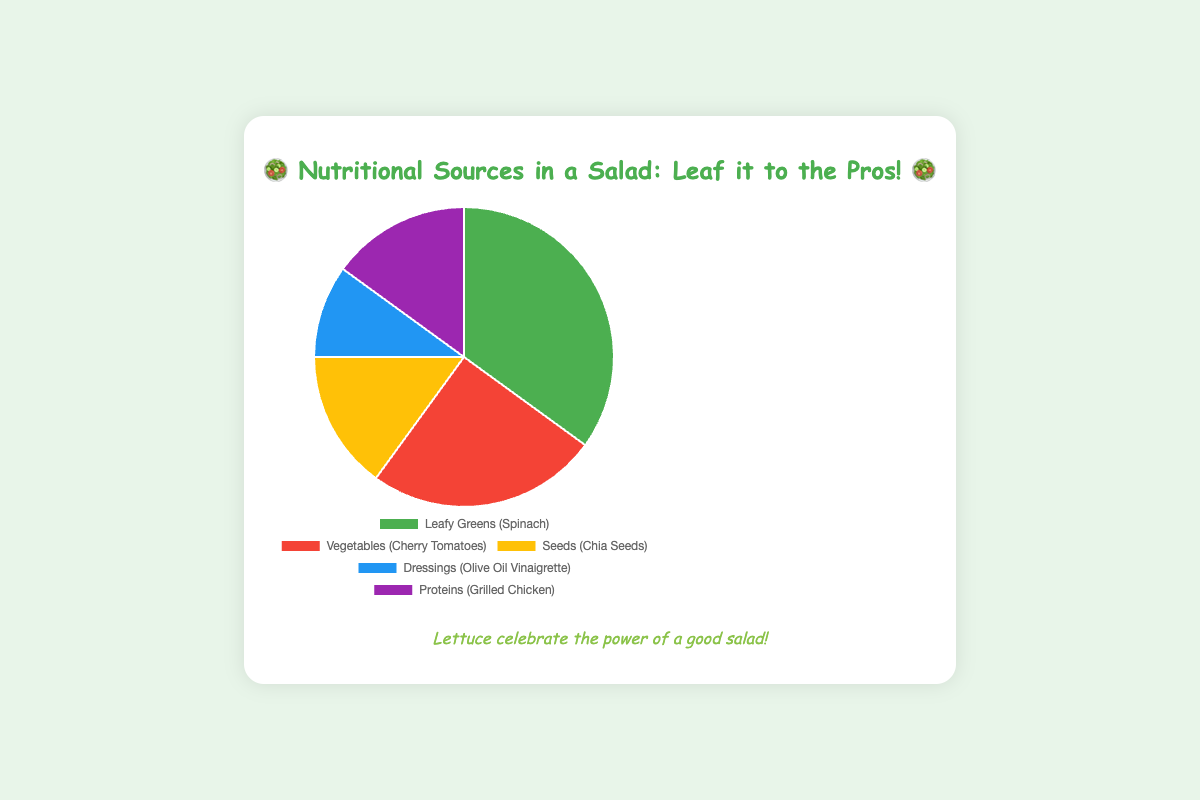What is the source with the highest nutritional value percentage in the salad? The figure shows the sources of nutritional value in a pie chart with percentages. The part of the pie chart labeled "Leafy Greens (Spinach)" represents the largest portion.
Answer: Leafy Greens (Spinach) How much more nutritional value do Leafy Greens (Spinach) provide compared to Dressings (Olive Oil Vinaigrette)? Leafy Greens (Spinach) provide 35%, and Dressings (Olive Oil Vinaigrette) provide 10%. The difference in their nutritional value is calculated by subtracting 10 from 35.
Answer: 25% What's the combined percentage of nutritional value from Seeds (Chia Seeds) and Proteins (Grilled Chicken)? Seeds (Chia Seeds) account for 15% and Proteins (Grilled Chicken) account for 15%. The combined percentage is the sum of these two values.
Answer: 30% Which category has an equal percentage of nutritional value to Seeds (Chia Seeds)? The chart shows that both Seeds (Chia Seeds) and Proteins (Grilled Chicken) have a 15% nutritional value each.
Answer: Proteins (Grilled Chicken) Out of Vegetables (Cherry Tomatoes) and Dressings (Olive Oil Vinaigrette), which source provides less nutritional value? From the chart, Vegetables (Cherry Tomatoes) provide 25%, whereas Dressings (Olive Oil Vinaigrette) provide 10%. Since 10% is less than 25%, Dressings have less nutritional value.
Answer: Dressings (Olive Oil Vinaigrette) How much more nutritional value does Vegetables (Cherry Tomatoes) provide compared to Proteins (Grilled Chicken)? Vegetables (Cherry Tomatoes) provide 25% and Proteins (Grilled Chicken) provide 15%. The difference is 25% minus 15%.
Answer: 10% By how much percentage does the nutritional value of Leafy Greens (Spinach) exceed the average value of all other sources? The average percentage of the other sources is calculated first. The other sources are Vegetables (25%), Seeds (15%), Dressings (10%), and Proteins (15%). The sum is 25 + 15 + 10 + 15 = 65, and the average is 65/4 = 16.25%. The difference between Leafy Greens (Spinach) at 35% and this average is calculated as 35 - 16.25.
Answer: 18.75% Which category has the second highest nutritional value in the salad? The largest percent is Leafy Greens (35%), and the second largest is Vegetables (25%). This makes Vegetables the second highest.
Answer: Vegetables (Cherry Tomatoes) If Seeds (Chia Seeds) and Proteins (Grilled Chicken) doubled their nutritional value, what would be their new combined percentage? Doubling the values of Seeds (15%) and Proteins (15%) means multiplying each by 2, resulting in 30% for each. Adding these together gives 30 + 30.
Answer: 60% 